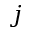<formula> <loc_0><loc_0><loc_500><loc_500>j</formula> 